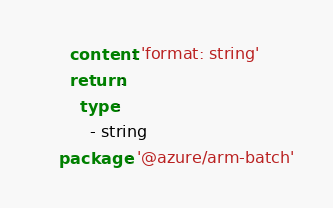Convert code to text. <code><loc_0><loc_0><loc_500><loc_500><_YAML_>      content: 'format: string'
      return:
        type:
          - string
    package: '@azure/arm-batch'
</code> 